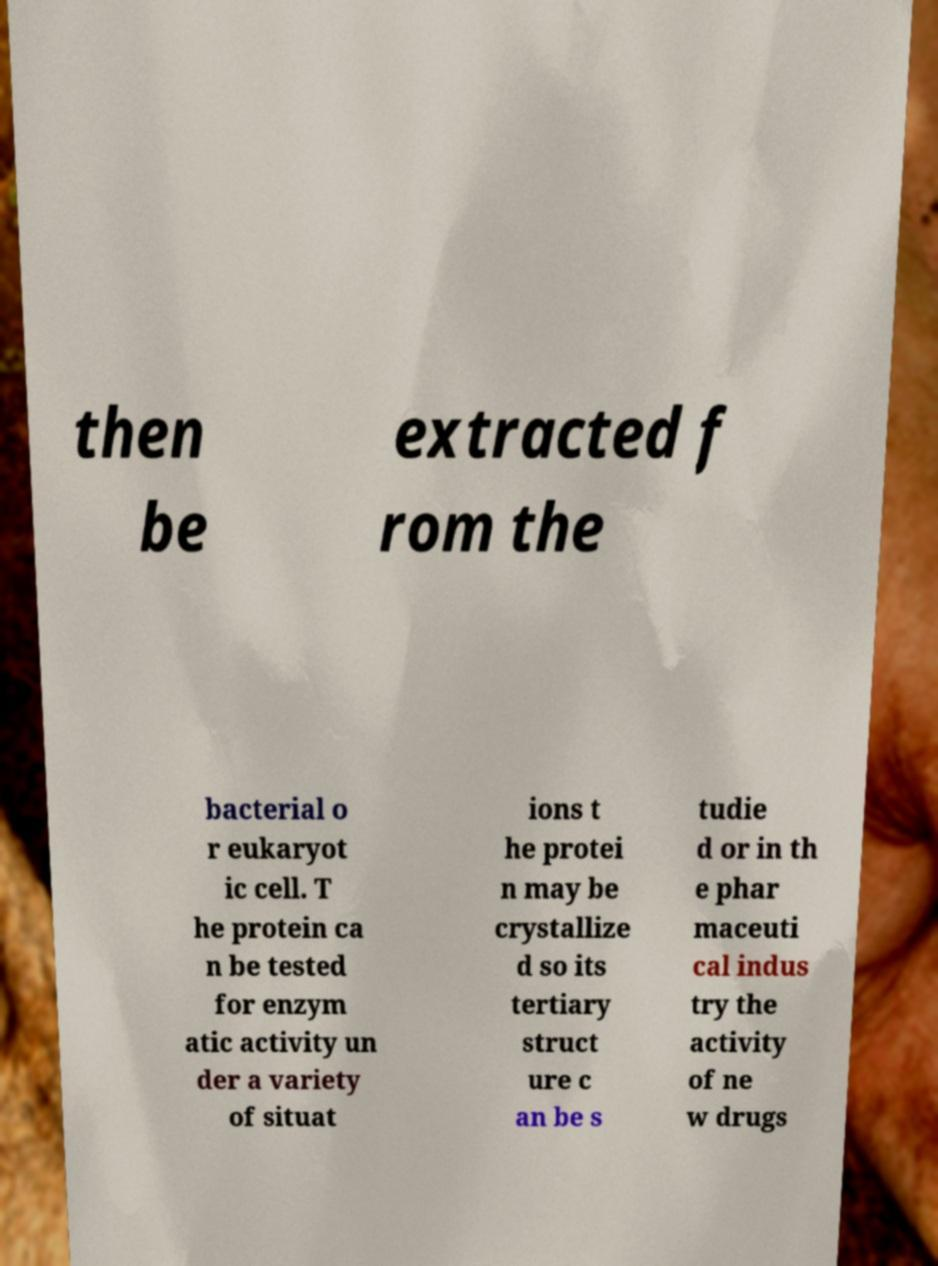Can you read and provide the text displayed in the image?This photo seems to have some interesting text. Can you extract and type it out for me? then be extracted f rom the bacterial o r eukaryot ic cell. T he protein ca n be tested for enzym atic activity un der a variety of situat ions t he protei n may be crystallize d so its tertiary struct ure c an be s tudie d or in th e phar maceuti cal indus try the activity of ne w drugs 